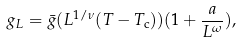Convert formula to latex. <formula><loc_0><loc_0><loc_500><loc_500>g _ { L } = \bar { g } ( L ^ { 1 / \nu } ( T - T _ { \text {c} } ) ) ( 1 + \frac { a } { L ^ { \omega } } ) ,</formula> 